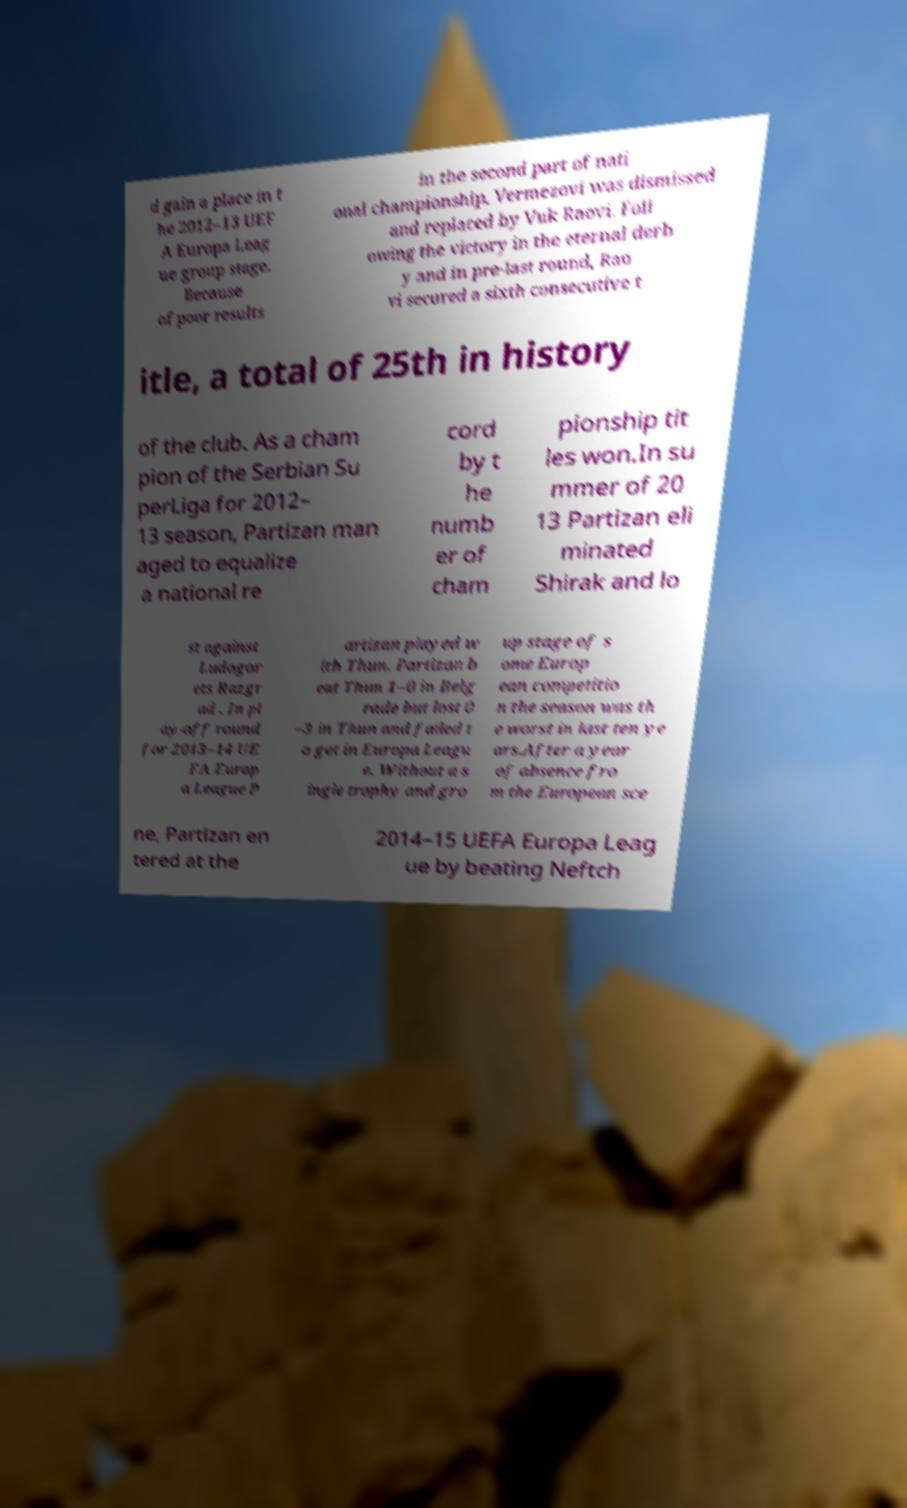Could you extract and type out the text from this image? d gain a place in t he 2012–13 UEF A Europa Leag ue group stage. Because of poor results in the second part of nati onal championship, Vermezovi was dismissed and replaced by Vuk Raovi. Foll owing the victory in the eternal derb y and in pre-last round, Rao vi secured a sixth consecutive t itle, a total of 25th in history of the club. As a cham pion of the Serbian Su perLiga for 2012– 13 season, Partizan man aged to equalize a national re cord by t he numb er of cham pionship tit les won.In su mmer of 20 13 Partizan eli minated Shirak and lo st against Ludogor ets Razgr ad . In pl ay-off round for 2013–14 UE FA Europ a League P artizan played w ith Thun. Partizan b eat Thun 1–0 in Belg rade but lost 0 –3 in Thun and failed t o get in Europa Leagu e. Without a s ingle trophy and gro up stage of s ome Europ ean competitio n the season was th e worst in last ten ye ars.After a year of absence fro m the European sce ne, Partizan en tered at the 2014–15 UEFA Europa Leag ue by beating Neftch 